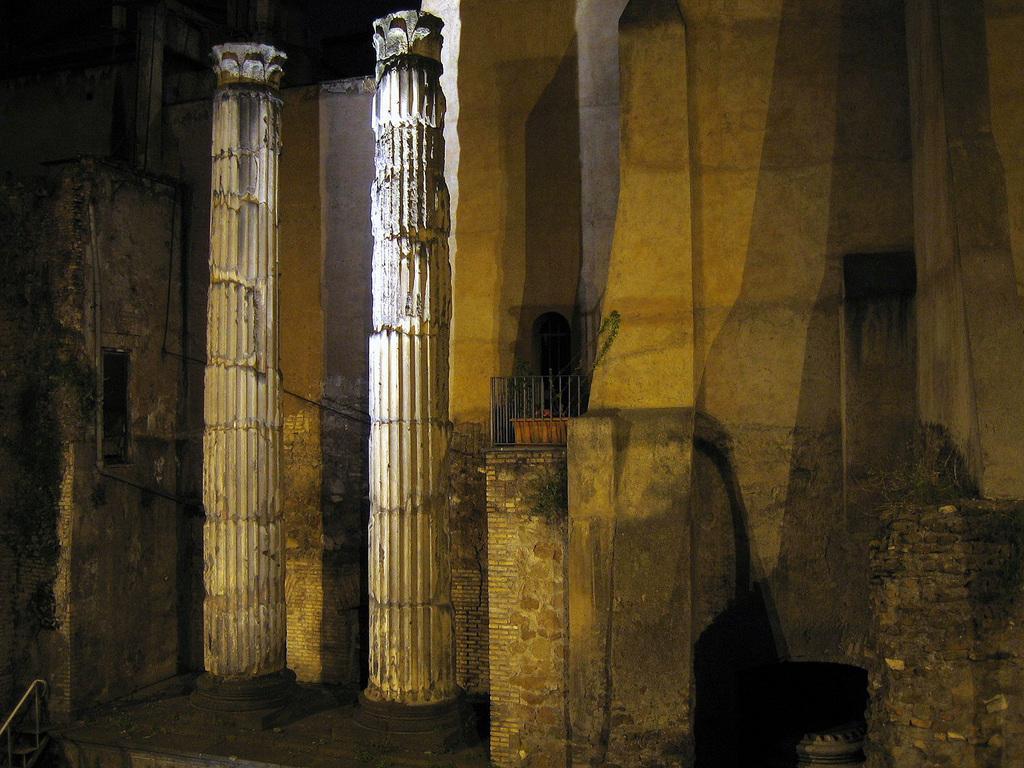Can you describe this image briefly? In this image there are pillars, wall, grille and plant pot. 